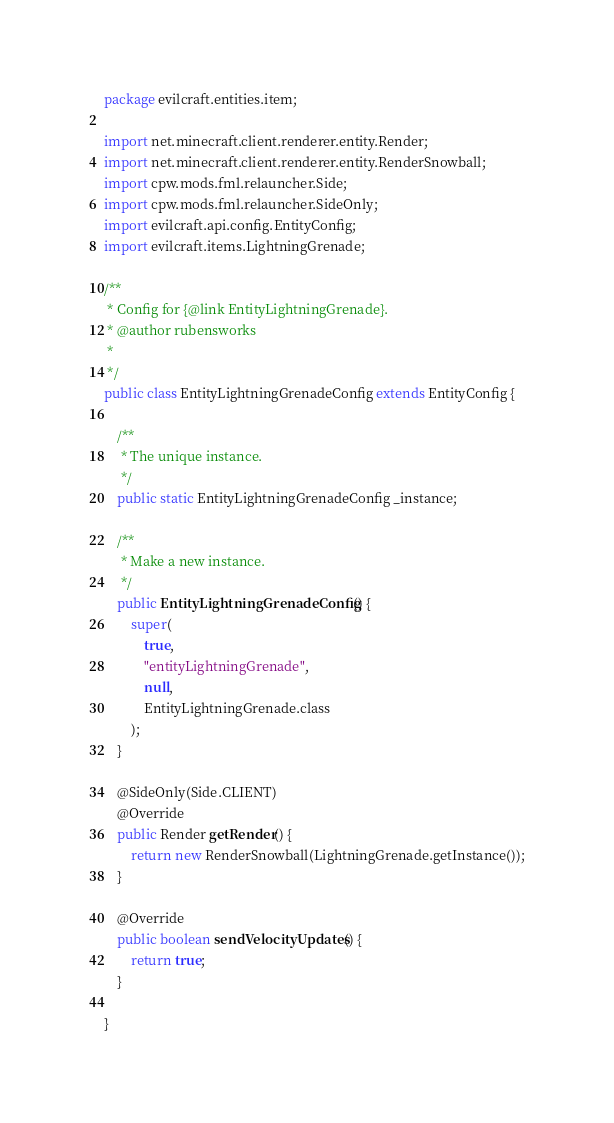<code> <loc_0><loc_0><loc_500><loc_500><_Java_>package evilcraft.entities.item;

import net.minecraft.client.renderer.entity.Render;
import net.minecraft.client.renderer.entity.RenderSnowball;
import cpw.mods.fml.relauncher.Side;
import cpw.mods.fml.relauncher.SideOnly;
import evilcraft.api.config.EntityConfig;
import evilcraft.items.LightningGrenade;

/**
 * Config for {@link EntityLightningGrenade}.
 * @author rubensworks
 *
 */
public class EntityLightningGrenadeConfig extends EntityConfig {
    
    /**
     * The unique instance.
     */
    public static EntityLightningGrenadeConfig _instance;

    /**
     * Make a new instance.
     */
    public EntityLightningGrenadeConfig() {
        super(
        	true,
            "entityLightningGrenade",
            null,
            EntityLightningGrenade.class
        );
    }

    @SideOnly(Side.CLIENT)
    @Override
    public Render getRender() {
        return new RenderSnowball(LightningGrenade.getInstance());
    }
    
    @Override
    public boolean sendVelocityUpdates() {
        return true;
    }
    
}
</code> 